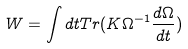<formula> <loc_0><loc_0><loc_500><loc_500>W = \int d t T r ( K \Omega ^ { - 1 } \frac { d \Omega } { d t } )</formula> 